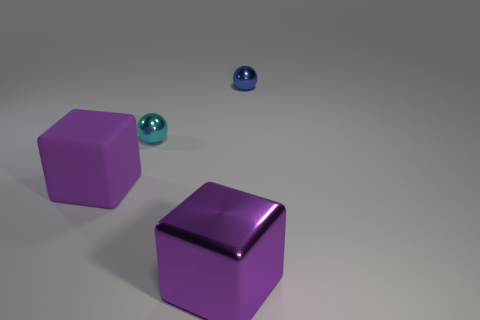Are there any large purple shiny things that have the same shape as the small cyan thing?
Keep it short and to the point. No. What number of things are big purple cubes left of the tiny cyan object or metallic balls?
Provide a short and direct response. 3. There is another cube that is the same color as the big metallic cube; what is its size?
Make the answer very short. Large. There is a small thing in front of the blue metallic object; is its color the same as the object that is behind the cyan metal ball?
Ensure brevity in your answer.  No. What is the size of the blue thing?
Your answer should be very brief. Small. How many big objects are either green rubber objects or blue metallic balls?
Offer a very short reply. 0. What color is the shiny ball that is the same size as the cyan metallic object?
Your answer should be very brief. Blue. What number of other objects are the same shape as the blue thing?
Offer a very short reply. 1. Is there a tiny cyan sphere that has the same material as the blue thing?
Your answer should be very brief. Yes. Do the large purple cube that is behind the purple metal cube and the sphere behind the cyan metallic thing have the same material?
Give a very brief answer. No. 